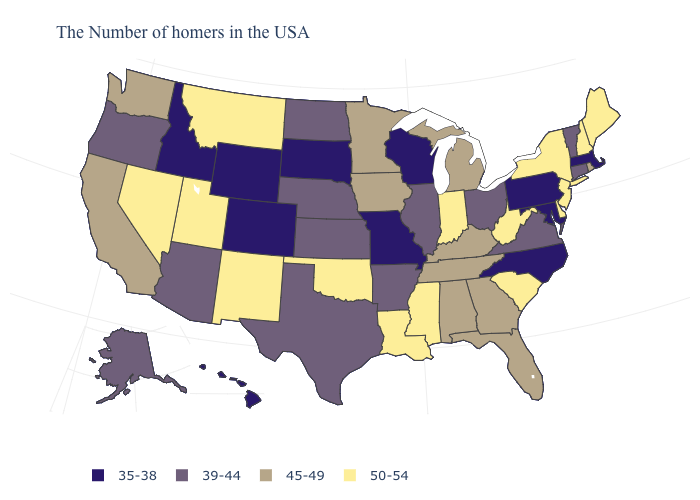What is the value of Rhode Island?
Short answer required. 45-49. How many symbols are there in the legend?
Write a very short answer. 4. Which states hav the highest value in the South?
Answer briefly. Delaware, South Carolina, West Virginia, Mississippi, Louisiana, Oklahoma. Name the states that have a value in the range 35-38?
Answer briefly. Massachusetts, Maryland, Pennsylvania, North Carolina, Wisconsin, Missouri, South Dakota, Wyoming, Colorado, Idaho, Hawaii. What is the value of Idaho?
Give a very brief answer. 35-38. Does Texas have the lowest value in the South?
Be succinct. No. What is the lowest value in states that border Texas?
Write a very short answer. 39-44. What is the lowest value in the USA?
Give a very brief answer. 35-38. Name the states that have a value in the range 50-54?
Quick response, please. Maine, New Hampshire, New York, New Jersey, Delaware, South Carolina, West Virginia, Indiana, Mississippi, Louisiana, Oklahoma, New Mexico, Utah, Montana, Nevada. Name the states that have a value in the range 39-44?
Be succinct. Vermont, Connecticut, Virginia, Ohio, Illinois, Arkansas, Kansas, Nebraska, Texas, North Dakota, Arizona, Oregon, Alaska. What is the lowest value in the MidWest?
Write a very short answer. 35-38. Which states have the highest value in the USA?
Quick response, please. Maine, New Hampshire, New York, New Jersey, Delaware, South Carolina, West Virginia, Indiana, Mississippi, Louisiana, Oklahoma, New Mexico, Utah, Montana, Nevada. What is the value of New Hampshire?
Quick response, please. 50-54. Does the first symbol in the legend represent the smallest category?
Answer briefly. Yes. Does Arizona have the lowest value in the West?
Short answer required. No. 